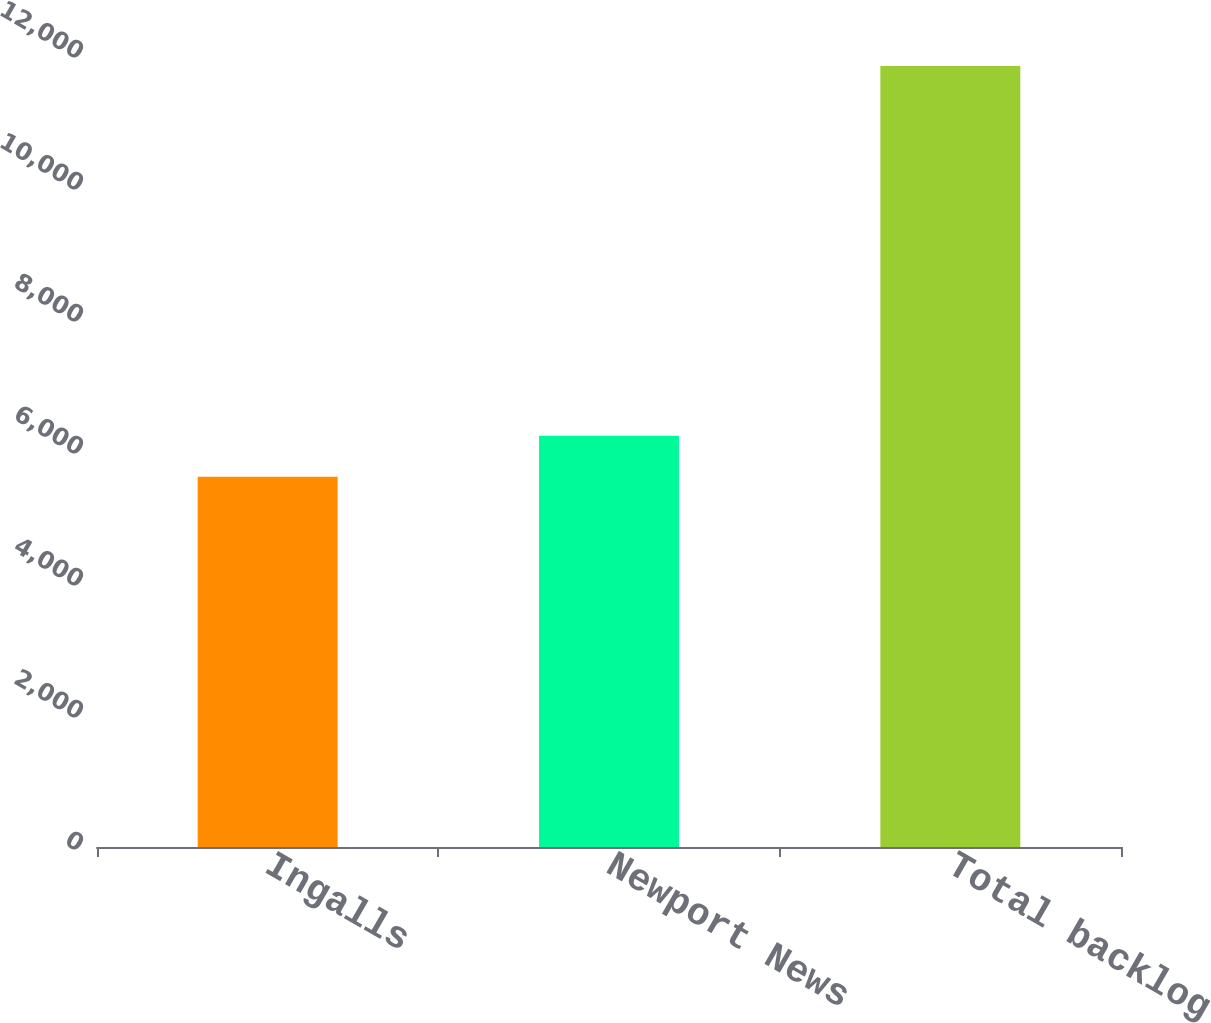Convert chart to OTSL. <chart><loc_0><loc_0><loc_500><loc_500><bar_chart><fcel>Ingalls<fcel>Newport News<fcel>Total backlog<nl><fcel>5609<fcel>6231.3<fcel>11832<nl></chart> 